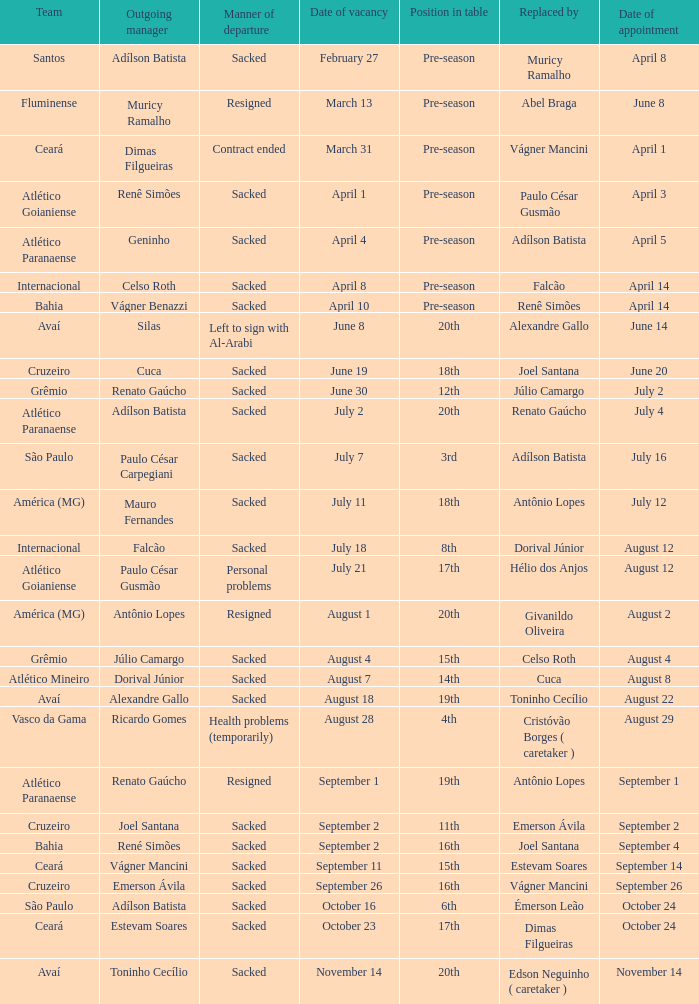Write the full table. {'header': ['Team', 'Outgoing manager', 'Manner of departure', 'Date of vacancy', 'Position in table', 'Replaced by', 'Date of appointment'], 'rows': [['Santos', 'Adílson Batista', 'Sacked', 'February 27', 'Pre-season', 'Muricy Ramalho', 'April 8'], ['Fluminense', 'Muricy Ramalho', 'Resigned', 'March 13', 'Pre-season', 'Abel Braga', 'June 8'], ['Ceará', 'Dimas Filgueiras', 'Contract ended', 'March 31', 'Pre-season', 'Vágner Mancini', 'April 1'], ['Atlético Goianiense', 'Renê Simões', 'Sacked', 'April 1', 'Pre-season', 'Paulo César Gusmão', 'April 3'], ['Atlético Paranaense', 'Geninho', 'Sacked', 'April 4', 'Pre-season', 'Adílson Batista', 'April 5'], ['Internacional', 'Celso Roth', 'Sacked', 'April 8', 'Pre-season', 'Falcão', 'April 14'], ['Bahia', 'Vágner Benazzi', 'Sacked', 'April 10', 'Pre-season', 'Renê Simões', 'April 14'], ['Avaí', 'Silas', 'Left to sign with Al-Arabi', 'June 8', '20th', 'Alexandre Gallo', 'June 14'], ['Cruzeiro', 'Cuca', 'Sacked', 'June 19', '18th', 'Joel Santana', 'June 20'], ['Grêmio', 'Renato Gaúcho', 'Sacked', 'June 30', '12th', 'Júlio Camargo', 'July 2'], ['Atlético Paranaense', 'Adílson Batista', 'Sacked', 'July 2', '20th', 'Renato Gaúcho', 'July 4'], ['São Paulo', 'Paulo César Carpegiani', 'Sacked', 'July 7', '3rd', 'Adílson Batista', 'July 16'], ['América (MG)', 'Mauro Fernandes', 'Sacked', 'July 11', '18th', 'Antônio Lopes', 'July 12'], ['Internacional', 'Falcão', 'Sacked', 'July 18', '8th', 'Dorival Júnior', 'August 12'], ['Atlético Goianiense', 'Paulo César Gusmão', 'Personal problems', 'July 21', '17th', 'Hélio dos Anjos', 'August 12'], ['América (MG)', 'Antônio Lopes', 'Resigned', 'August 1', '20th', 'Givanildo Oliveira', 'August 2'], ['Grêmio', 'Júlio Camargo', 'Sacked', 'August 4', '15th', 'Celso Roth', 'August 4'], ['Atlético Mineiro', 'Dorival Júnior', 'Sacked', 'August 7', '14th', 'Cuca', 'August 8'], ['Avaí', 'Alexandre Gallo', 'Sacked', 'August 18', '19th', 'Toninho Cecílio', 'August 22'], ['Vasco da Gama', 'Ricardo Gomes', 'Health problems (temporarily)', 'August 28', '4th', 'Cristóvão Borges ( caretaker )', 'August 29'], ['Atlético Paranaense', 'Renato Gaúcho', 'Resigned', 'September 1', '19th', 'Antônio Lopes', 'September 1'], ['Cruzeiro', 'Joel Santana', 'Sacked', 'September 2', '11th', 'Emerson Ávila', 'September 2'], ['Bahia', 'René Simões', 'Sacked', 'September 2', '16th', 'Joel Santana', 'September 4'], ['Ceará', 'Vágner Mancini', 'Sacked', 'September 11', '15th', 'Estevam Soares', 'September 14'], ['Cruzeiro', 'Emerson Ávila', 'Sacked', 'September 26', '16th', 'Vágner Mancini', 'September 26'], ['São Paulo', 'Adílson Batista', 'Sacked', 'October 16', '6th', 'Émerson Leão', 'October 24'], ['Ceará', 'Estevam Soares', 'Sacked', 'October 23', '17th', 'Dimas Filgueiras', 'October 24'], ['Avaí', 'Toninho Cecílio', 'Sacked', 'November 14', '20th', 'Edson Neguinho ( caretaker )', 'November 14']]} Why did Geninho leave as manager? Sacked. 